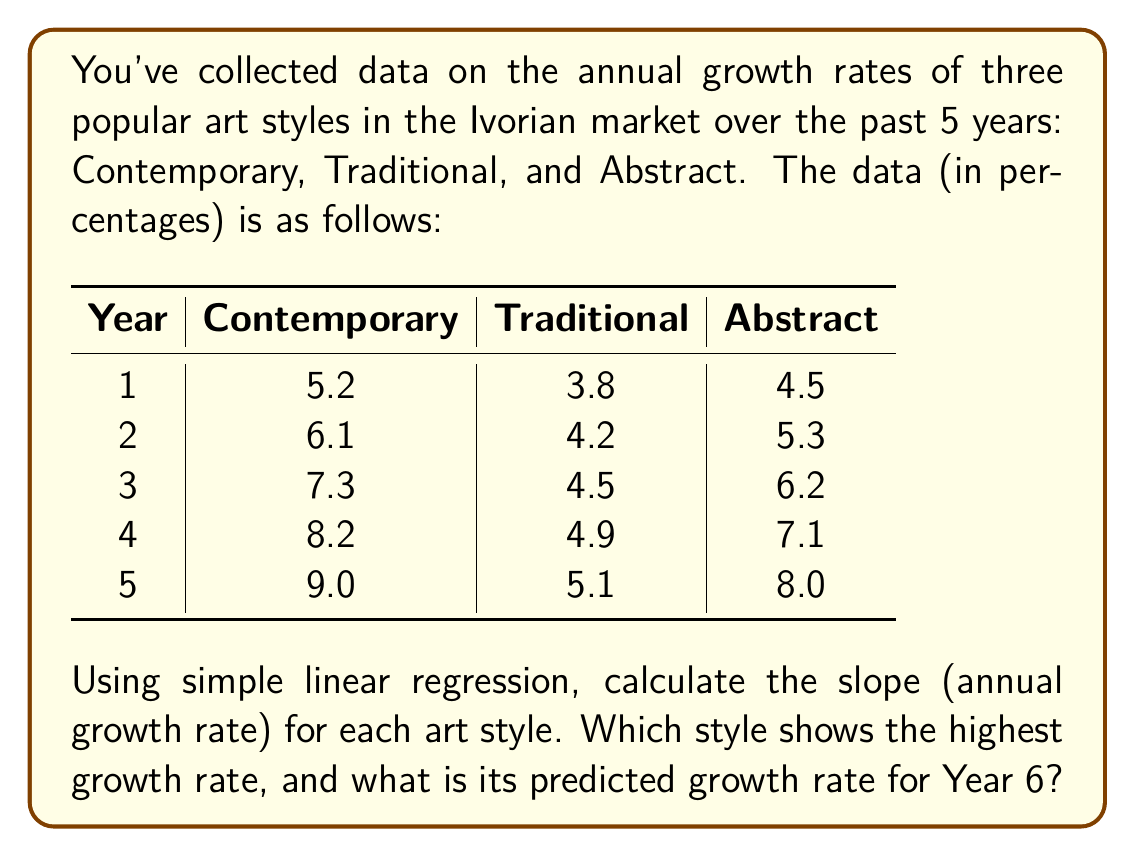Teach me how to tackle this problem. To solve this problem, we'll use simple linear regression for each art style. The formula for the slope (m) in a simple linear regression is:

$$ m = \frac{n\sum xy - \sum x \sum y}{n\sum x^2 - (\sum x)^2} $$

Where n is the number of data points, x represents the year, and y represents the growth rate.

For each art style:

1. Contemporary:
$\sum x = 15$, $\sum y = 35.8$, $\sum xy = 125.9$, $\sum x^2 = 55$
$$ m_{contemporary} = \frac{5(125.9) - 15(35.8)}{5(55) - 15^2} = 0.97 $$

2. Traditional:
$\sum x = 15$, $\sum y = 22.5$, $\sum xy = 77.3$, $\sum x^2 = 55$
$$ m_{traditional} = \frac{5(77.3) - 15(22.5)}{5(55) - 15^2} = 0.33 $$

3. Abstract:
$\sum x = 15$, $\sum y = 31.1$, $\sum xy = 108.7$, $\sum x^2 = 55$
$$ m_{abstract} = \frac{5(108.7) - 15(31.1)}{5(55) - 15^2} = 0.89 $$

The Contemporary style shows the highest growth rate at 0.97% per year.

To predict the growth rate for Year 6, we use the equation:
$$ y = mx + b $$
Where b is the y-intercept, calculated as:
$$ b = \bar{y} - m\bar{x} $$

For Contemporary:
$$ b = 7.16 - 0.97(3) = 4.25 $$
$$ y = 0.97(6) + 4.25 = 10.07 $$

Therefore, the predicted growth rate for Contemporary art in Year 6 is 10.07%.
Answer: Contemporary art; 10.07% 